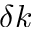Convert formula to latex. <formula><loc_0><loc_0><loc_500><loc_500>\delta k</formula> 